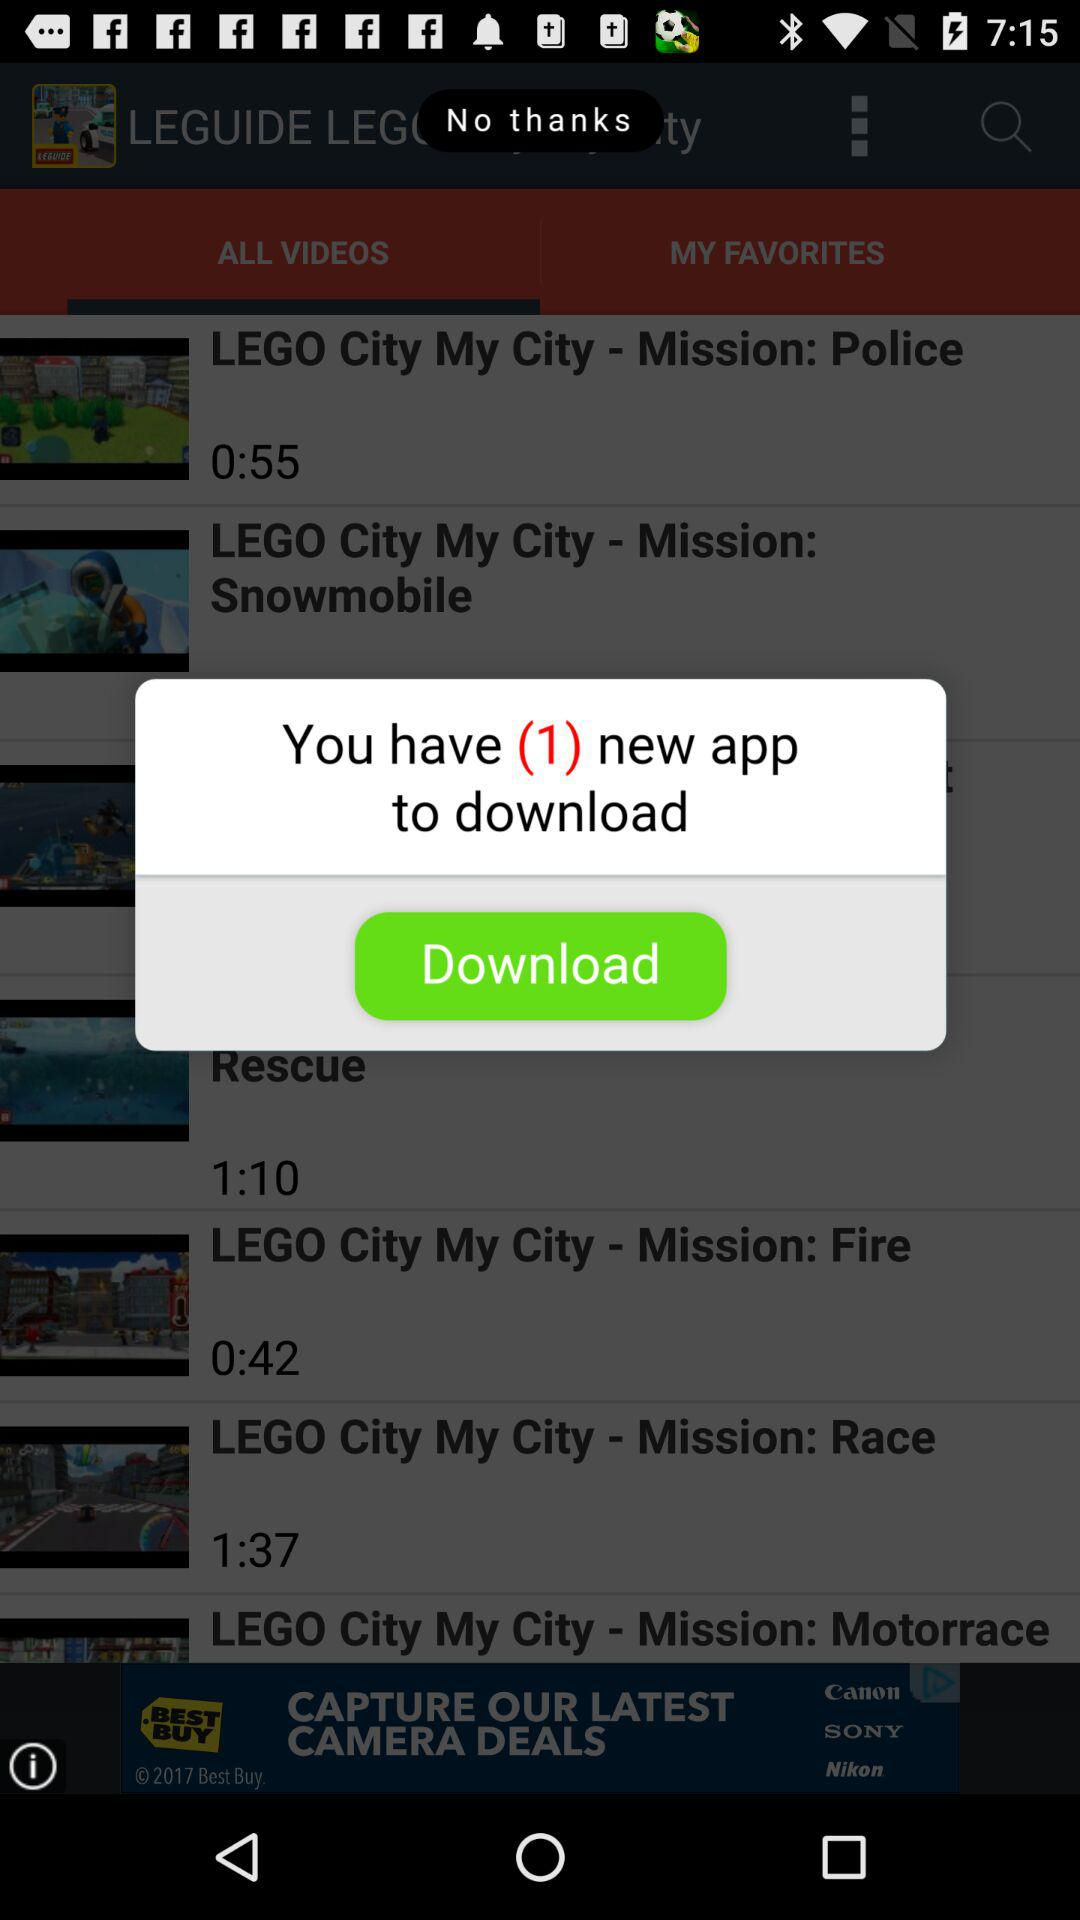How many new apps are there to download? There is 1 new app to download. 